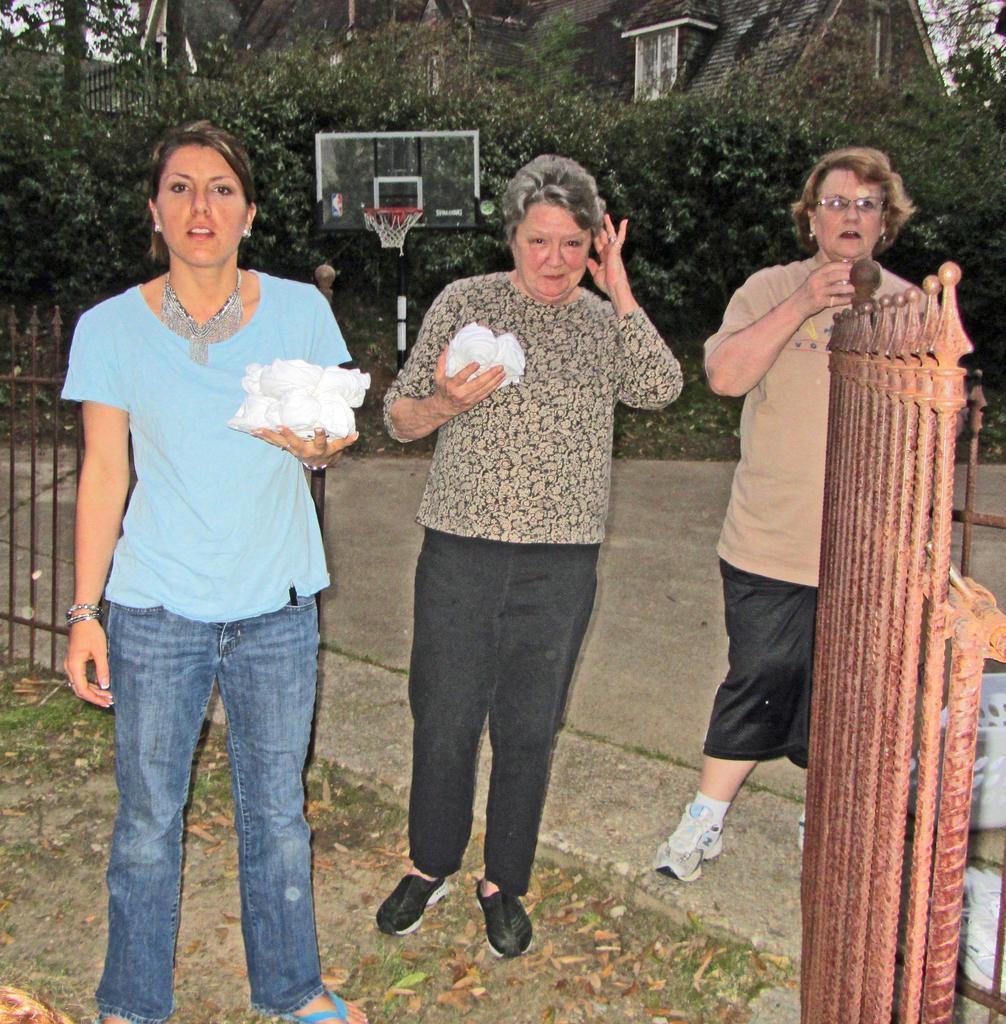Could you give a brief overview of what you see in this image? In this image we can see three persons, among them two persons are holding objects, there is a basketball net, there are some trees, houses, fence and leaves on the ground. 